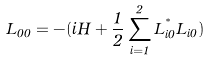<formula> <loc_0><loc_0><loc_500><loc_500>L _ { 0 0 } = - ( i H + \frac { 1 } { 2 } \sum _ { i = 1 } ^ { 2 } L _ { i 0 } ^ { ^ { * } } L _ { i 0 } )</formula> 